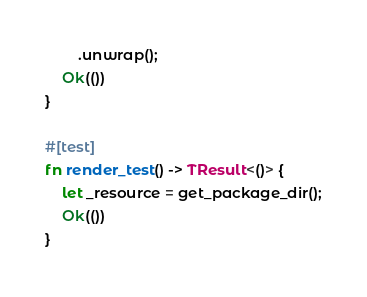Convert code to text. <code><loc_0><loc_0><loc_500><loc_500><_Rust_>        .unwrap();
    Ok(())
}

#[test]
fn render_test() -> TResult<()> {
    let _resource = get_package_dir();
    Ok(())
}
</code> 